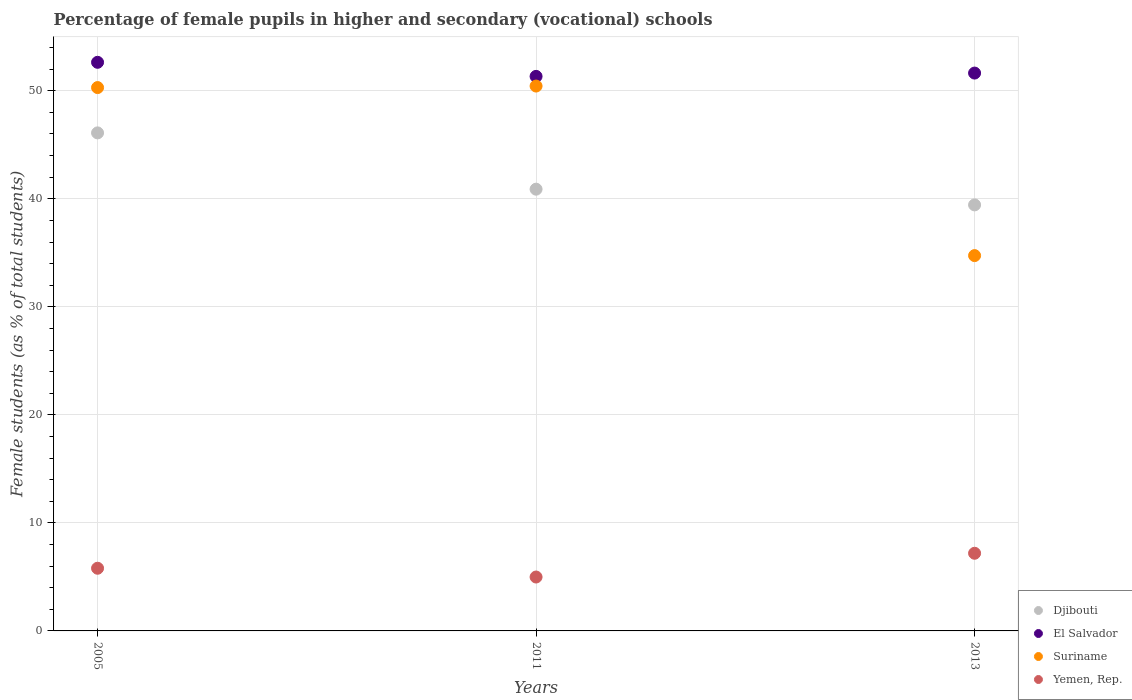What is the percentage of female pupils in higher and secondary schools in Djibouti in 2013?
Offer a very short reply. 39.44. Across all years, what is the maximum percentage of female pupils in higher and secondary schools in El Salvador?
Keep it short and to the point. 52.63. Across all years, what is the minimum percentage of female pupils in higher and secondary schools in Yemen, Rep.?
Offer a very short reply. 4.99. In which year was the percentage of female pupils in higher and secondary schools in El Salvador maximum?
Keep it short and to the point. 2005. In which year was the percentage of female pupils in higher and secondary schools in Suriname minimum?
Your response must be concise. 2013. What is the total percentage of female pupils in higher and secondary schools in Yemen, Rep. in the graph?
Give a very brief answer. 17.98. What is the difference between the percentage of female pupils in higher and secondary schools in Djibouti in 2005 and that in 2011?
Provide a short and direct response. 5.21. What is the difference between the percentage of female pupils in higher and secondary schools in Djibouti in 2011 and the percentage of female pupils in higher and secondary schools in Suriname in 2005?
Keep it short and to the point. -9.41. What is the average percentage of female pupils in higher and secondary schools in Suriname per year?
Offer a very short reply. 45.16. In the year 2011, what is the difference between the percentage of female pupils in higher and secondary schools in Suriname and percentage of female pupils in higher and secondary schools in Yemen, Rep.?
Offer a very short reply. 45.45. What is the ratio of the percentage of female pupils in higher and secondary schools in Yemen, Rep. in 2005 to that in 2011?
Keep it short and to the point. 1.16. What is the difference between the highest and the second highest percentage of female pupils in higher and secondary schools in Suriname?
Provide a short and direct response. 0.14. What is the difference between the highest and the lowest percentage of female pupils in higher and secondary schools in Yemen, Rep.?
Your answer should be very brief. 2.2. In how many years, is the percentage of female pupils in higher and secondary schools in Suriname greater than the average percentage of female pupils in higher and secondary schools in Suriname taken over all years?
Ensure brevity in your answer.  2. Is it the case that in every year, the sum of the percentage of female pupils in higher and secondary schools in Yemen, Rep. and percentage of female pupils in higher and secondary schools in El Salvador  is greater than the sum of percentage of female pupils in higher and secondary schools in Suriname and percentage of female pupils in higher and secondary schools in Djibouti?
Give a very brief answer. Yes. Does the percentage of female pupils in higher and secondary schools in Suriname monotonically increase over the years?
Your answer should be very brief. No. Is the percentage of female pupils in higher and secondary schools in Djibouti strictly greater than the percentage of female pupils in higher and secondary schools in Suriname over the years?
Give a very brief answer. No. How many dotlines are there?
Give a very brief answer. 4. How many years are there in the graph?
Your response must be concise. 3. Are the values on the major ticks of Y-axis written in scientific E-notation?
Offer a terse response. No. Where does the legend appear in the graph?
Your response must be concise. Bottom right. What is the title of the graph?
Your response must be concise. Percentage of female pupils in higher and secondary (vocational) schools. Does "High income: OECD" appear as one of the legend labels in the graph?
Offer a terse response. No. What is the label or title of the X-axis?
Provide a succinct answer. Years. What is the label or title of the Y-axis?
Provide a succinct answer. Female students (as % of total students). What is the Female students (as % of total students) in Djibouti in 2005?
Your answer should be compact. 46.1. What is the Female students (as % of total students) of El Salvador in 2005?
Keep it short and to the point. 52.63. What is the Female students (as % of total students) of Suriname in 2005?
Keep it short and to the point. 50.3. What is the Female students (as % of total students) of Yemen, Rep. in 2005?
Make the answer very short. 5.8. What is the Female students (as % of total students) in Djibouti in 2011?
Your response must be concise. 40.89. What is the Female students (as % of total students) of El Salvador in 2011?
Give a very brief answer. 51.33. What is the Female students (as % of total students) of Suriname in 2011?
Provide a succinct answer. 50.44. What is the Female students (as % of total students) of Yemen, Rep. in 2011?
Your answer should be compact. 4.99. What is the Female students (as % of total students) of Djibouti in 2013?
Your response must be concise. 39.44. What is the Female students (as % of total students) of El Salvador in 2013?
Your answer should be compact. 51.64. What is the Female students (as % of total students) in Suriname in 2013?
Offer a very short reply. 34.74. What is the Female students (as % of total students) in Yemen, Rep. in 2013?
Ensure brevity in your answer.  7.19. Across all years, what is the maximum Female students (as % of total students) of Djibouti?
Your answer should be very brief. 46.1. Across all years, what is the maximum Female students (as % of total students) in El Salvador?
Provide a succinct answer. 52.63. Across all years, what is the maximum Female students (as % of total students) of Suriname?
Keep it short and to the point. 50.44. Across all years, what is the maximum Female students (as % of total students) of Yemen, Rep.?
Provide a succinct answer. 7.19. Across all years, what is the minimum Female students (as % of total students) in Djibouti?
Offer a terse response. 39.44. Across all years, what is the minimum Female students (as % of total students) of El Salvador?
Your response must be concise. 51.33. Across all years, what is the minimum Female students (as % of total students) of Suriname?
Keep it short and to the point. 34.74. Across all years, what is the minimum Female students (as % of total students) of Yemen, Rep.?
Keep it short and to the point. 4.99. What is the total Female students (as % of total students) of Djibouti in the graph?
Provide a short and direct response. 126.43. What is the total Female students (as % of total students) in El Salvador in the graph?
Make the answer very short. 155.6. What is the total Female students (as % of total students) in Suriname in the graph?
Your answer should be very brief. 135.47. What is the total Female students (as % of total students) in Yemen, Rep. in the graph?
Offer a terse response. 17.98. What is the difference between the Female students (as % of total students) of Djibouti in 2005 and that in 2011?
Provide a short and direct response. 5.21. What is the difference between the Female students (as % of total students) of El Salvador in 2005 and that in 2011?
Keep it short and to the point. 1.3. What is the difference between the Female students (as % of total students) of Suriname in 2005 and that in 2011?
Your answer should be compact. -0.14. What is the difference between the Female students (as % of total students) of Yemen, Rep. in 2005 and that in 2011?
Offer a very short reply. 0.81. What is the difference between the Female students (as % of total students) of Djibouti in 2005 and that in 2013?
Your response must be concise. 6.67. What is the difference between the Female students (as % of total students) in Suriname in 2005 and that in 2013?
Your answer should be very brief. 15.55. What is the difference between the Female students (as % of total students) of Yemen, Rep. in 2005 and that in 2013?
Your answer should be compact. -1.39. What is the difference between the Female students (as % of total students) of Djibouti in 2011 and that in 2013?
Ensure brevity in your answer.  1.45. What is the difference between the Female students (as % of total students) of El Salvador in 2011 and that in 2013?
Provide a succinct answer. -0.31. What is the difference between the Female students (as % of total students) of Suriname in 2011 and that in 2013?
Offer a very short reply. 15.69. What is the difference between the Female students (as % of total students) in Yemen, Rep. in 2011 and that in 2013?
Provide a short and direct response. -2.2. What is the difference between the Female students (as % of total students) of Djibouti in 2005 and the Female students (as % of total students) of El Salvador in 2011?
Offer a terse response. -5.23. What is the difference between the Female students (as % of total students) of Djibouti in 2005 and the Female students (as % of total students) of Suriname in 2011?
Offer a very short reply. -4.33. What is the difference between the Female students (as % of total students) in Djibouti in 2005 and the Female students (as % of total students) in Yemen, Rep. in 2011?
Give a very brief answer. 41.11. What is the difference between the Female students (as % of total students) in El Salvador in 2005 and the Female students (as % of total students) in Suriname in 2011?
Offer a very short reply. 2.2. What is the difference between the Female students (as % of total students) of El Salvador in 2005 and the Female students (as % of total students) of Yemen, Rep. in 2011?
Offer a very short reply. 47.64. What is the difference between the Female students (as % of total students) of Suriname in 2005 and the Female students (as % of total students) of Yemen, Rep. in 2011?
Give a very brief answer. 45.31. What is the difference between the Female students (as % of total students) of Djibouti in 2005 and the Female students (as % of total students) of El Salvador in 2013?
Your response must be concise. -5.54. What is the difference between the Female students (as % of total students) in Djibouti in 2005 and the Female students (as % of total students) in Suriname in 2013?
Provide a succinct answer. 11.36. What is the difference between the Female students (as % of total students) of Djibouti in 2005 and the Female students (as % of total students) of Yemen, Rep. in 2013?
Provide a short and direct response. 38.91. What is the difference between the Female students (as % of total students) in El Salvador in 2005 and the Female students (as % of total students) in Suriname in 2013?
Ensure brevity in your answer.  17.89. What is the difference between the Female students (as % of total students) of El Salvador in 2005 and the Female students (as % of total students) of Yemen, Rep. in 2013?
Ensure brevity in your answer.  45.45. What is the difference between the Female students (as % of total students) in Suriname in 2005 and the Female students (as % of total students) in Yemen, Rep. in 2013?
Keep it short and to the point. 43.11. What is the difference between the Female students (as % of total students) of Djibouti in 2011 and the Female students (as % of total students) of El Salvador in 2013?
Your response must be concise. -10.75. What is the difference between the Female students (as % of total students) in Djibouti in 2011 and the Female students (as % of total students) in Suriname in 2013?
Ensure brevity in your answer.  6.15. What is the difference between the Female students (as % of total students) in Djibouti in 2011 and the Female students (as % of total students) in Yemen, Rep. in 2013?
Give a very brief answer. 33.7. What is the difference between the Female students (as % of total students) in El Salvador in 2011 and the Female students (as % of total students) in Suriname in 2013?
Provide a short and direct response. 16.59. What is the difference between the Female students (as % of total students) in El Salvador in 2011 and the Female students (as % of total students) in Yemen, Rep. in 2013?
Your answer should be very brief. 44.14. What is the difference between the Female students (as % of total students) of Suriname in 2011 and the Female students (as % of total students) of Yemen, Rep. in 2013?
Offer a terse response. 43.25. What is the average Female students (as % of total students) of Djibouti per year?
Offer a very short reply. 42.14. What is the average Female students (as % of total students) in El Salvador per year?
Offer a very short reply. 51.87. What is the average Female students (as % of total students) of Suriname per year?
Your answer should be compact. 45.16. What is the average Female students (as % of total students) of Yemen, Rep. per year?
Provide a short and direct response. 5.99. In the year 2005, what is the difference between the Female students (as % of total students) of Djibouti and Female students (as % of total students) of El Salvador?
Keep it short and to the point. -6.53. In the year 2005, what is the difference between the Female students (as % of total students) of Djibouti and Female students (as % of total students) of Suriname?
Give a very brief answer. -4.19. In the year 2005, what is the difference between the Female students (as % of total students) of Djibouti and Female students (as % of total students) of Yemen, Rep.?
Keep it short and to the point. 40.3. In the year 2005, what is the difference between the Female students (as % of total students) in El Salvador and Female students (as % of total students) in Suriname?
Ensure brevity in your answer.  2.34. In the year 2005, what is the difference between the Female students (as % of total students) in El Salvador and Female students (as % of total students) in Yemen, Rep.?
Your response must be concise. 46.83. In the year 2005, what is the difference between the Female students (as % of total students) in Suriname and Female students (as % of total students) in Yemen, Rep.?
Give a very brief answer. 44.49. In the year 2011, what is the difference between the Female students (as % of total students) of Djibouti and Female students (as % of total students) of El Salvador?
Offer a very short reply. -10.44. In the year 2011, what is the difference between the Female students (as % of total students) of Djibouti and Female students (as % of total students) of Suriname?
Your response must be concise. -9.55. In the year 2011, what is the difference between the Female students (as % of total students) in Djibouti and Female students (as % of total students) in Yemen, Rep.?
Offer a very short reply. 35.9. In the year 2011, what is the difference between the Female students (as % of total students) of El Salvador and Female students (as % of total students) of Suriname?
Provide a succinct answer. 0.9. In the year 2011, what is the difference between the Female students (as % of total students) of El Salvador and Female students (as % of total students) of Yemen, Rep.?
Give a very brief answer. 46.34. In the year 2011, what is the difference between the Female students (as % of total students) of Suriname and Female students (as % of total students) of Yemen, Rep.?
Make the answer very short. 45.45. In the year 2013, what is the difference between the Female students (as % of total students) in Djibouti and Female students (as % of total students) in El Salvador?
Provide a short and direct response. -12.2. In the year 2013, what is the difference between the Female students (as % of total students) of Djibouti and Female students (as % of total students) of Suriname?
Make the answer very short. 4.69. In the year 2013, what is the difference between the Female students (as % of total students) in Djibouti and Female students (as % of total students) in Yemen, Rep.?
Your answer should be very brief. 32.25. In the year 2013, what is the difference between the Female students (as % of total students) of El Salvador and Female students (as % of total students) of Suriname?
Give a very brief answer. 16.9. In the year 2013, what is the difference between the Female students (as % of total students) in El Salvador and Female students (as % of total students) in Yemen, Rep.?
Your answer should be very brief. 44.45. In the year 2013, what is the difference between the Female students (as % of total students) of Suriname and Female students (as % of total students) of Yemen, Rep.?
Make the answer very short. 27.55. What is the ratio of the Female students (as % of total students) of Djibouti in 2005 to that in 2011?
Provide a succinct answer. 1.13. What is the ratio of the Female students (as % of total students) in El Salvador in 2005 to that in 2011?
Provide a succinct answer. 1.03. What is the ratio of the Female students (as % of total students) of Yemen, Rep. in 2005 to that in 2011?
Ensure brevity in your answer.  1.16. What is the ratio of the Female students (as % of total students) in Djibouti in 2005 to that in 2013?
Offer a very short reply. 1.17. What is the ratio of the Female students (as % of total students) in El Salvador in 2005 to that in 2013?
Provide a short and direct response. 1.02. What is the ratio of the Female students (as % of total students) of Suriname in 2005 to that in 2013?
Your answer should be compact. 1.45. What is the ratio of the Female students (as % of total students) in Yemen, Rep. in 2005 to that in 2013?
Your answer should be very brief. 0.81. What is the ratio of the Female students (as % of total students) in Djibouti in 2011 to that in 2013?
Ensure brevity in your answer.  1.04. What is the ratio of the Female students (as % of total students) in Suriname in 2011 to that in 2013?
Your response must be concise. 1.45. What is the ratio of the Female students (as % of total students) in Yemen, Rep. in 2011 to that in 2013?
Ensure brevity in your answer.  0.69. What is the difference between the highest and the second highest Female students (as % of total students) of Djibouti?
Offer a very short reply. 5.21. What is the difference between the highest and the second highest Female students (as % of total students) in El Salvador?
Offer a very short reply. 1. What is the difference between the highest and the second highest Female students (as % of total students) of Suriname?
Offer a terse response. 0.14. What is the difference between the highest and the second highest Female students (as % of total students) in Yemen, Rep.?
Your response must be concise. 1.39. What is the difference between the highest and the lowest Female students (as % of total students) of Djibouti?
Give a very brief answer. 6.67. What is the difference between the highest and the lowest Female students (as % of total students) in El Salvador?
Keep it short and to the point. 1.3. What is the difference between the highest and the lowest Female students (as % of total students) in Suriname?
Your answer should be compact. 15.69. What is the difference between the highest and the lowest Female students (as % of total students) in Yemen, Rep.?
Offer a very short reply. 2.2. 